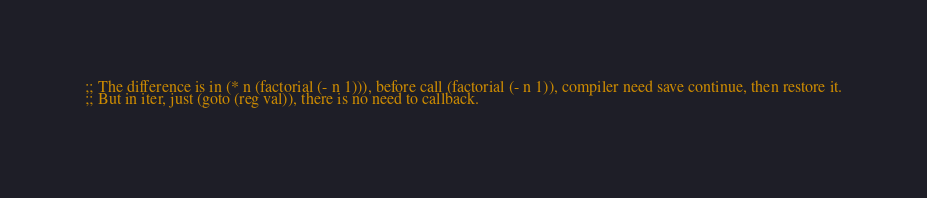<code> <loc_0><loc_0><loc_500><loc_500><_Scheme_> ;; The difference is in (* n (factorial (- n 1))), before call (factorial (- n 1)), compiler need save continue, then restore it. 
 ;; But in iter, just (goto (reg val)), there is no need to callback. 
 </code> 